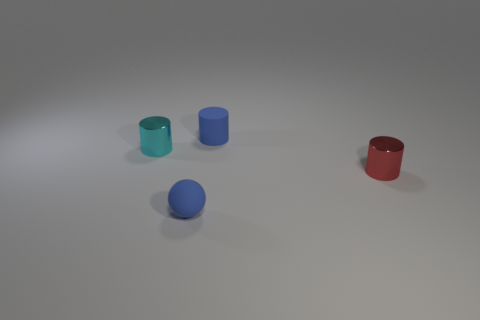There is a small rubber object that is behind the shiny thing that is to the left of the tiny rubber cylinder; is there a tiny object that is right of it?
Your answer should be very brief. Yes. What is the blue cylinder right of the small cyan cylinder made of?
Give a very brief answer. Rubber. There is a cyan metallic object; does it have the same shape as the blue matte thing that is to the left of the small blue matte cylinder?
Provide a short and direct response. No. Are there an equal number of things behind the red shiny object and tiny blue matte things that are in front of the matte cylinder?
Offer a terse response. No. How many other objects are there of the same material as the tiny cyan cylinder?
Offer a very short reply. 1. How many matte things are either small red objects or big brown objects?
Ensure brevity in your answer.  0. Is the shape of the small blue rubber object that is behind the blue rubber sphere the same as  the cyan object?
Make the answer very short. Yes. Is the number of cyan metallic cylinders in front of the blue ball greater than the number of large matte balls?
Offer a very short reply. No. What number of things are both on the left side of the red cylinder and in front of the tiny cyan metal cylinder?
Your response must be concise. 1. What color is the shiny thing that is behind the cylinder that is in front of the cyan object?
Offer a terse response. Cyan. 